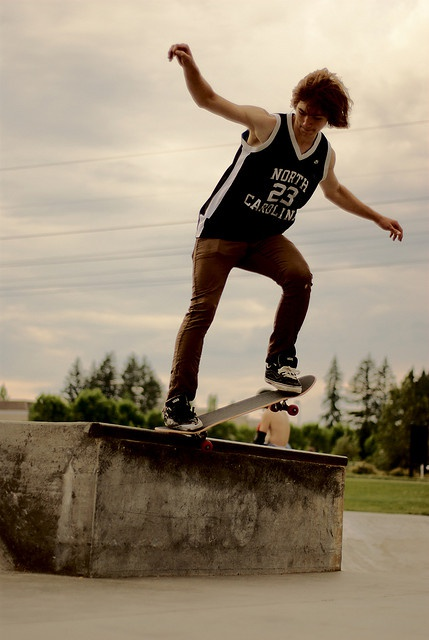Describe the objects in this image and their specific colors. I can see people in tan, black, maroon, and gray tones, skateboard in tan, gray, and black tones, and people in tan, gray, black, and brown tones in this image. 